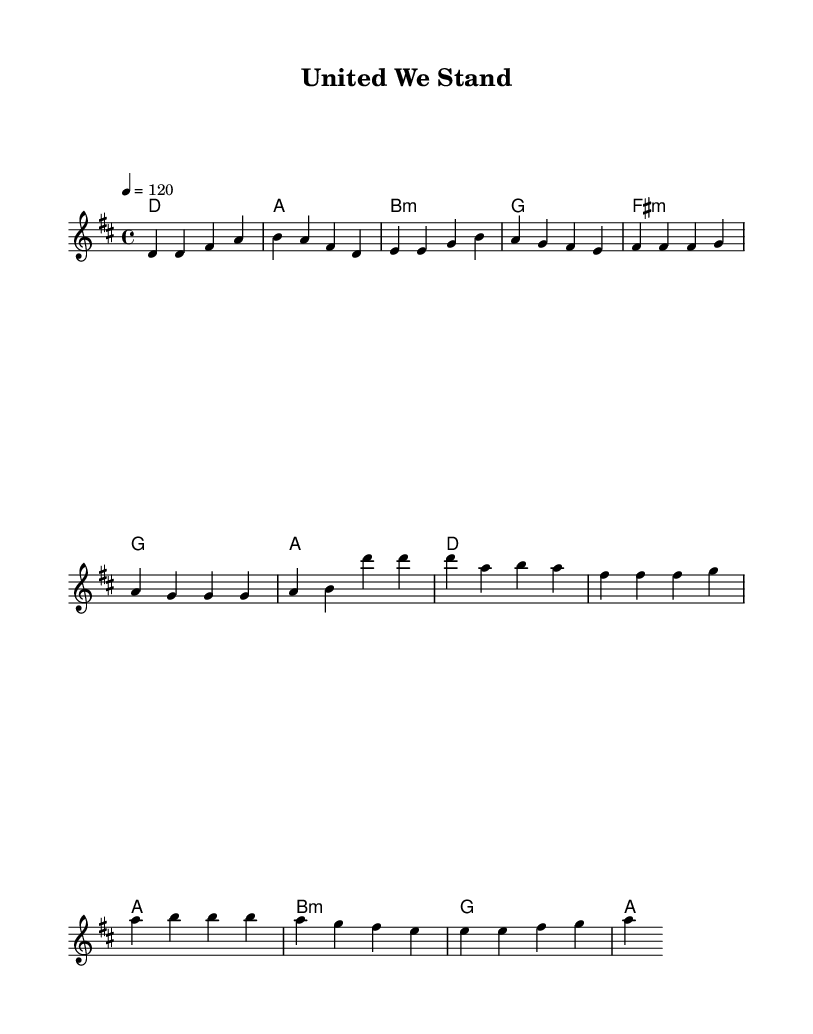What is the key signature of this music? The key signature indicated is D major, which has two sharps — F# and C#. This is deduced from the initial symbol shown at the beginning of the staff.
Answer: D major What is the time signature of this sheet music? The time signature displayed at the beginning of the piece is 4/4, indicating that there are four beats per measure and a quarter note receives one beat. This is identified from the 4/4 notation present in the score.
Answer: 4/4 What is the tempo marking of the music? The tempo is set at 120 beats per minute, shown by the tempo indication "4 = 120" placed at the start of the score. This means that the quarter note is played at 120 beats in one minute.
Answer: 120 What is the first chord in the verse? The first chord listed in the verse section is D major, as shown in the harmony section where the chord names align with the melody measures.
Answer: D How many measures are in the chorus section? The chorus section consists of four measures, which can be confirmed by counting the measures in the melody line from the indicated parts of the score.
Answer: 4 Which chord follows F# minor in the pre-chorus? The chord that follows F# minor in the pre-chorus is G major, as seen in the chord progression that transitions from F# minor to G major listed sequentially.
Answer: G What lyrics theme does the melody of this piece likely evoke? The melody is structured in a way that is typical for anthems celebrating worker solidarity, which often focuses on unity, empowerment, and collective strength, making this theme relevant based on the musical elements.
Answer: Solidarity 